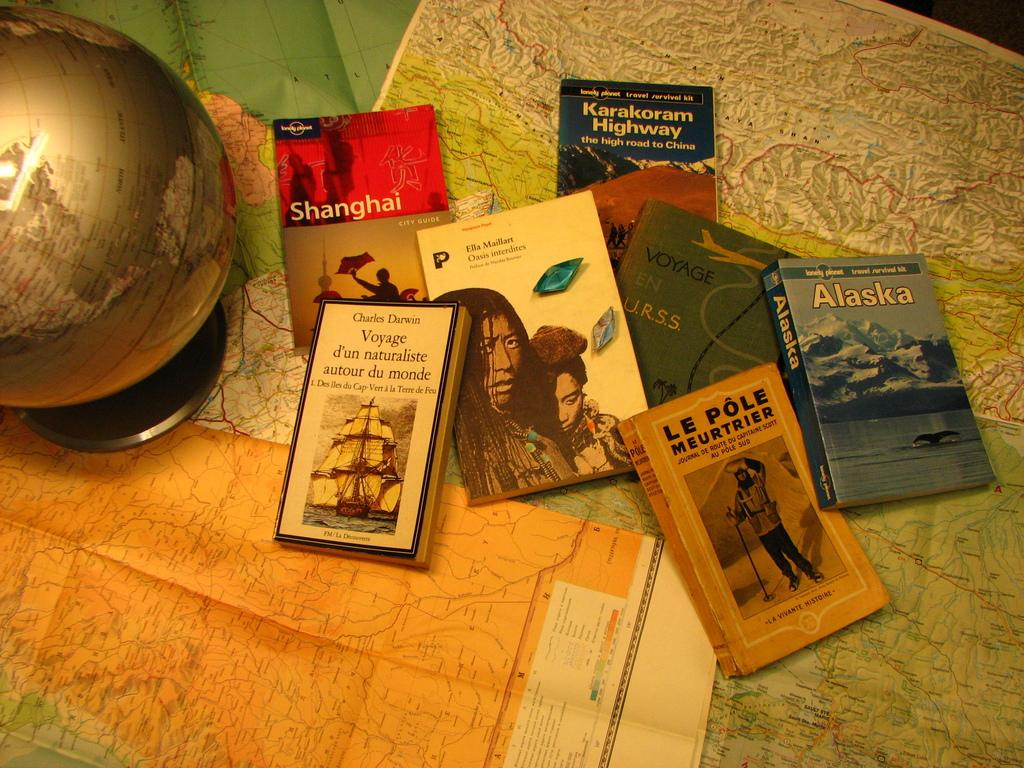<image>
Write a terse but informative summary of the picture. An assortment of books includes guides for Shanghai and Alaska. 